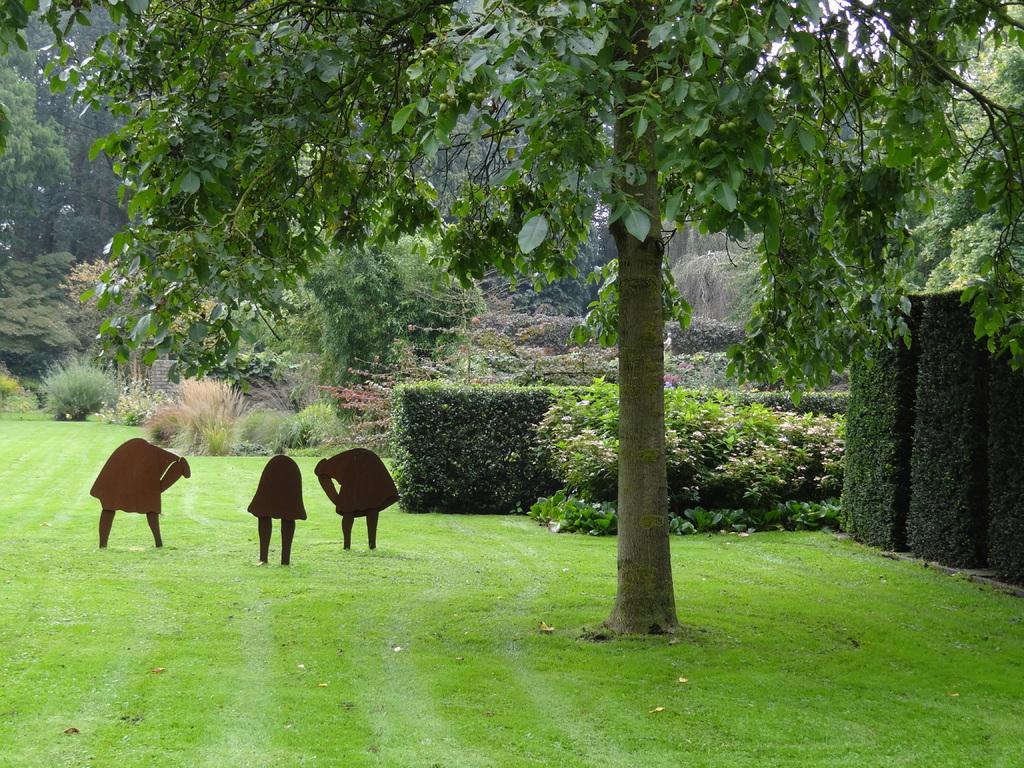Please provide a concise description of this image. In this image, we can see the ground covered with grass with some objects. We can see some plants and trees. 